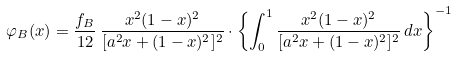Convert formula to latex. <formula><loc_0><loc_0><loc_500><loc_500>\varphi _ { B } ( x ) = \frac { f _ { B } } { 1 2 } \, \frac { x ^ { 2 } ( 1 - x ) ^ { 2 } } { [ a ^ { 2 } x + ( 1 - x ) ^ { 2 } ] ^ { 2 } } \cdot \left \{ \int _ { 0 } ^ { 1 } \frac { x ^ { 2 } ( 1 - x ) ^ { 2 } } { [ a ^ { 2 } x + ( 1 - x ) ^ { 2 } ] ^ { 2 } } \, d x \right \} ^ { - 1 }</formula> 